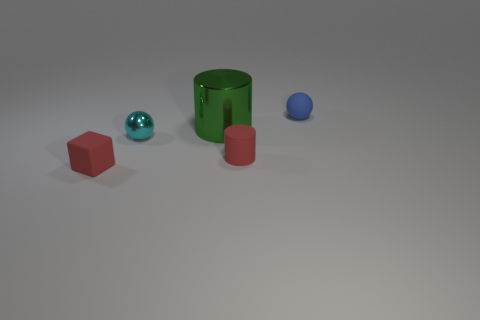Add 3 small cyan metal spheres. How many objects exist? 8 Subtract all spheres. How many objects are left? 3 Subtract 1 blocks. How many blocks are left? 0 Subtract all gray blocks. How many purple cylinders are left? 0 Subtract all small green rubber things. Subtract all matte balls. How many objects are left? 4 Add 3 red matte cylinders. How many red matte cylinders are left? 4 Add 1 green matte cubes. How many green matte cubes exist? 1 Subtract 0 brown cylinders. How many objects are left? 5 Subtract all brown cylinders. Subtract all brown cubes. How many cylinders are left? 2 